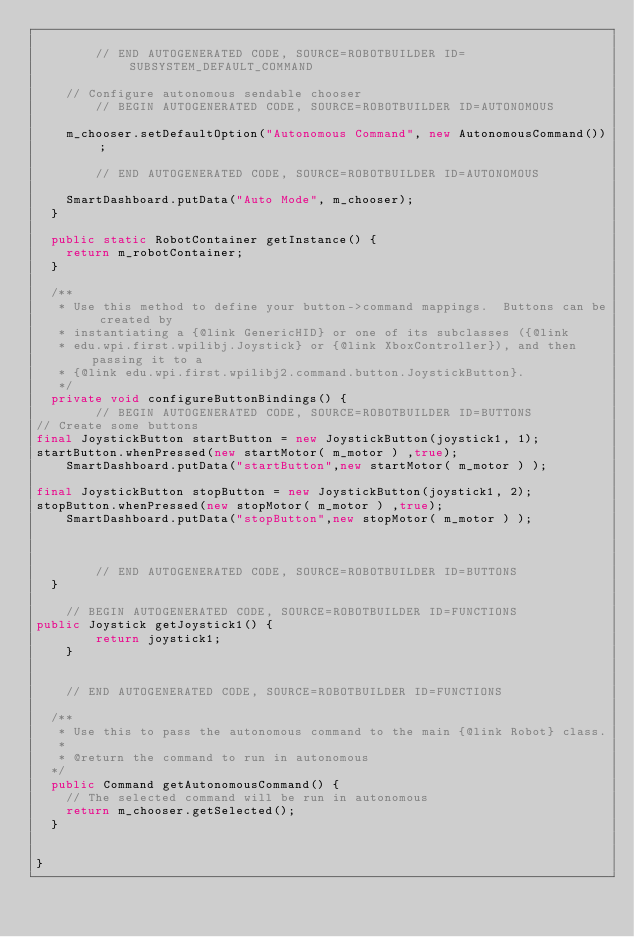Convert code to text. <code><loc_0><loc_0><loc_500><loc_500><_Java_>
        // END AUTOGENERATED CODE, SOURCE=ROBOTBUILDER ID=SUBSYSTEM_DEFAULT_COMMAND

    // Configure autonomous sendable chooser
        // BEGIN AUTOGENERATED CODE, SOURCE=ROBOTBUILDER ID=AUTONOMOUS

    m_chooser.setDefaultOption("Autonomous Command", new AutonomousCommand());

        // END AUTOGENERATED CODE, SOURCE=ROBOTBUILDER ID=AUTONOMOUS

    SmartDashboard.putData("Auto Mode", m_chooser);
  }

  public static RobotContainer getInstance() {
    return m_robotContainer;
  }

  /**
   * Use this method to define your button->command mappings.  Buttons can be created by
   * instantiating a {@link GenericHID} or one of its subclasses ({@link
   * edu.wpi.first.wpilibj.Joystick} or {@link XboxController}), and then passing it to a
   * {@link edu.wpi.first.wpilibj2.command.button.JoystickButton}.
   */
  private void configureButtonBindings() {
        // BEGIN AUTOGENERATED CODE, SOURCE=ROBOTBUILDER ID=BUTTONS
// Create some buttons
final JoystickButton startButton = new JoystickButton(joystick1, 1);        
startButton.whenPressed(new startMotor( m_motor ) ,true);
    SmartDashboard.putData("startButton",new startMotor( m_motor ) );

final JoystickButton stopButton = new JoystickButton(joystick1, 2);        
stopButton.whenPressed(new stopMotor( m_motor ) ,true);
    SmartDashboard.putData("stopButton",new stopMotor( m_motor ) );



        // END AUTOGENERATED CODE, SOURCE=ROBOTBUILDER ID=BUTTONS
  }

    // BEGIN AUTOGENERATED CODE, SOURCE=ROBOTBUILDER ID=FUNCTIONS
public Joystick getJoystick1() {
        return joystick1;
    }


    // END AUTOGENERATED CODE, SOURCE=ROBOTBUILDER ID=FUNCTIONS

  /**
   * Use this to pass the autonomous command to the main {@link Robot} class.
   *
   * @return the command to run in autonomous
  */
  public Command getAutonomousCommand() {
    // The selected command will be run in autonomous
    return m_chooser.getSelected();
  }
  

}

</code> 